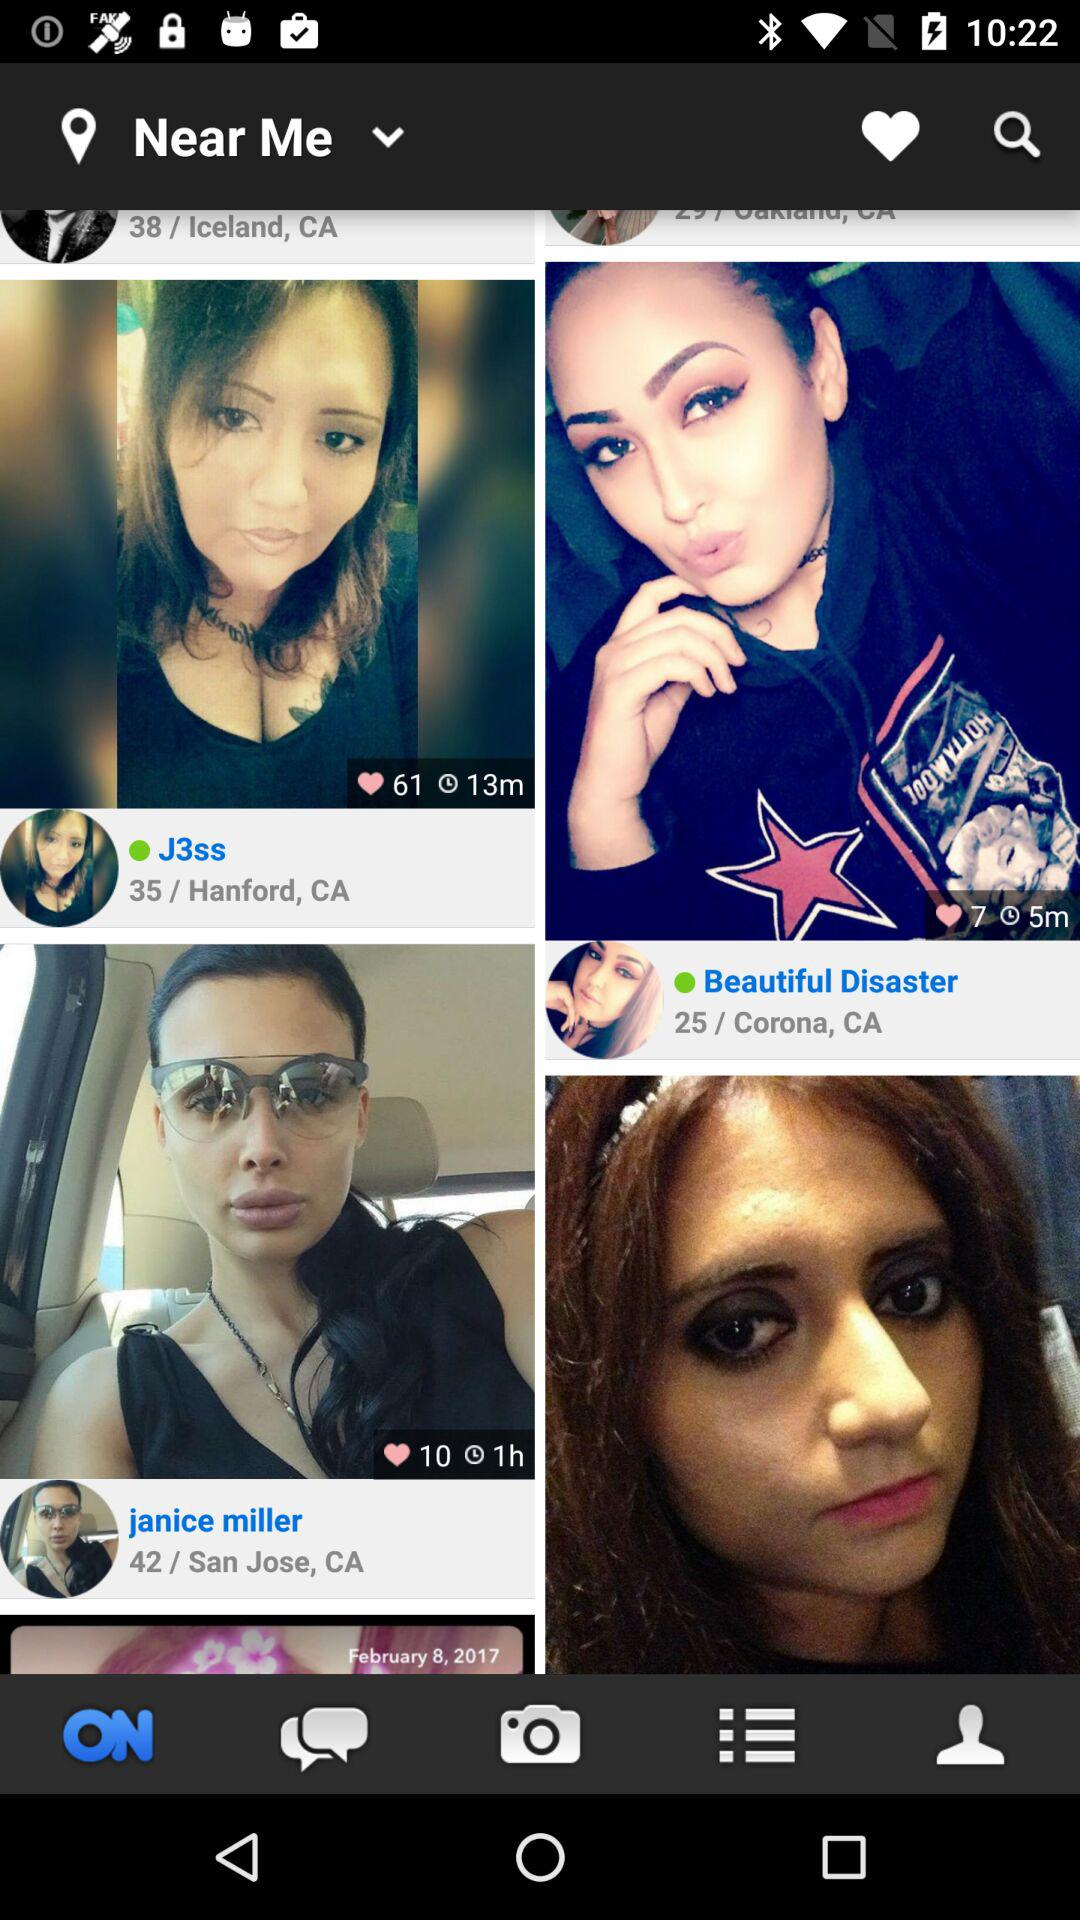How many people have a green circle?
Answer the question using a single word or phrase. 2 